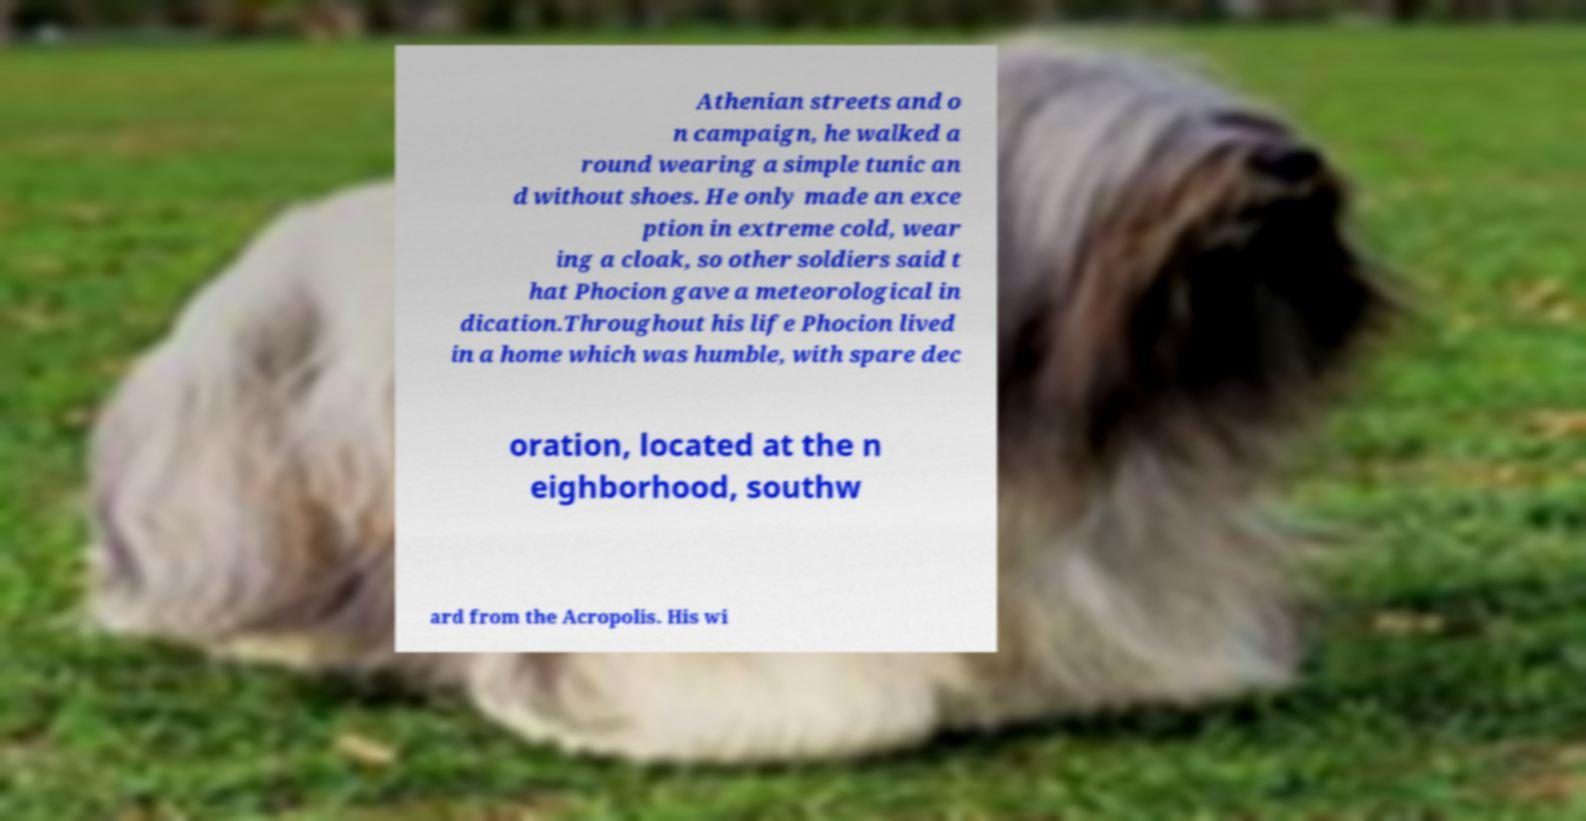What messages or text are displayed in this image? I need them in a readable, typed format. Athenian streets and o n campaign, he walked a round wearing a simple tunic an d without shoes. He only made an exce ption in extreme cold, wear ing a cloak, so other soldiers said t hat Phocion gave a meteorological in dication.Throughout his life Phocion lived in a home which was humble, with spare dec oration, located at the n eighborhood, southw ard from the Acropolis. His wi 